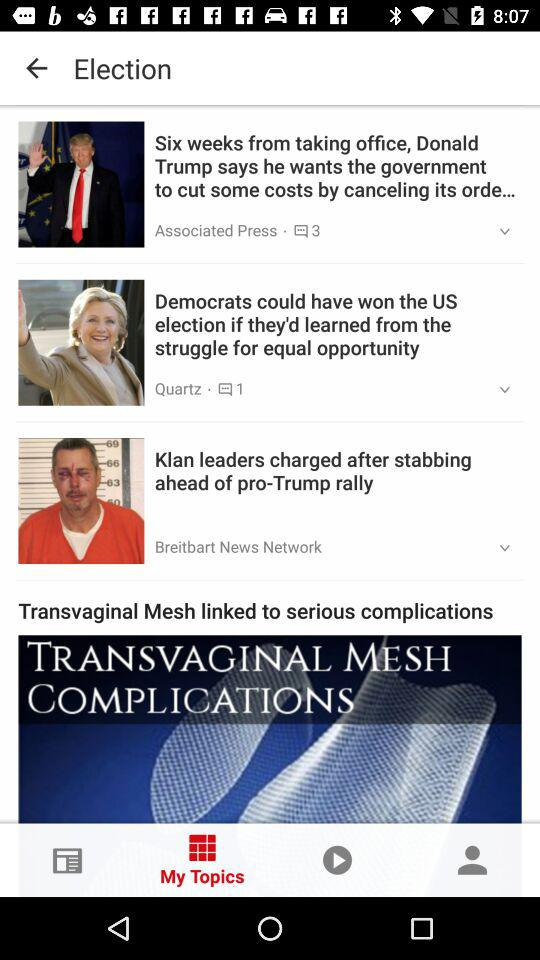How many stories are there in this news feed?
Answer the question using a single word or phrase. 4 